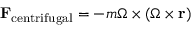Convert formula to latex. <formula><loc_0><loc_0><loc_500><loc_500>F _ { c e n t r i f u g a l } = - m { \Omega } \times ( { \Omega } \times r )</formula> 